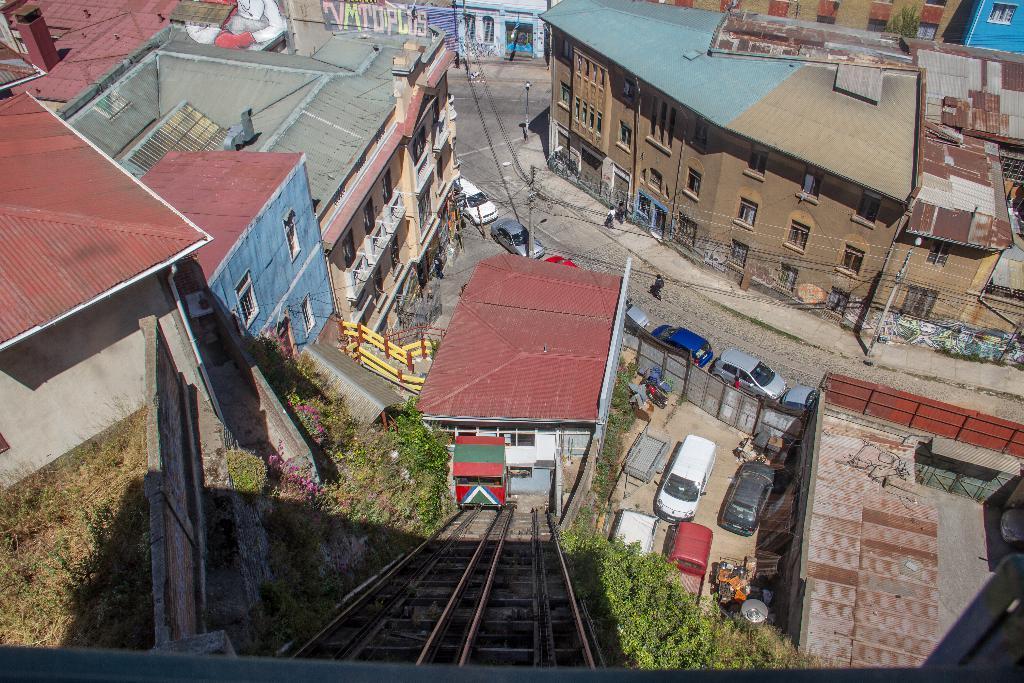Could you give a brief overview of what you see in this image? In this image we can see there are so many cars parked on the road, behind that there are so many buildings and plants. 